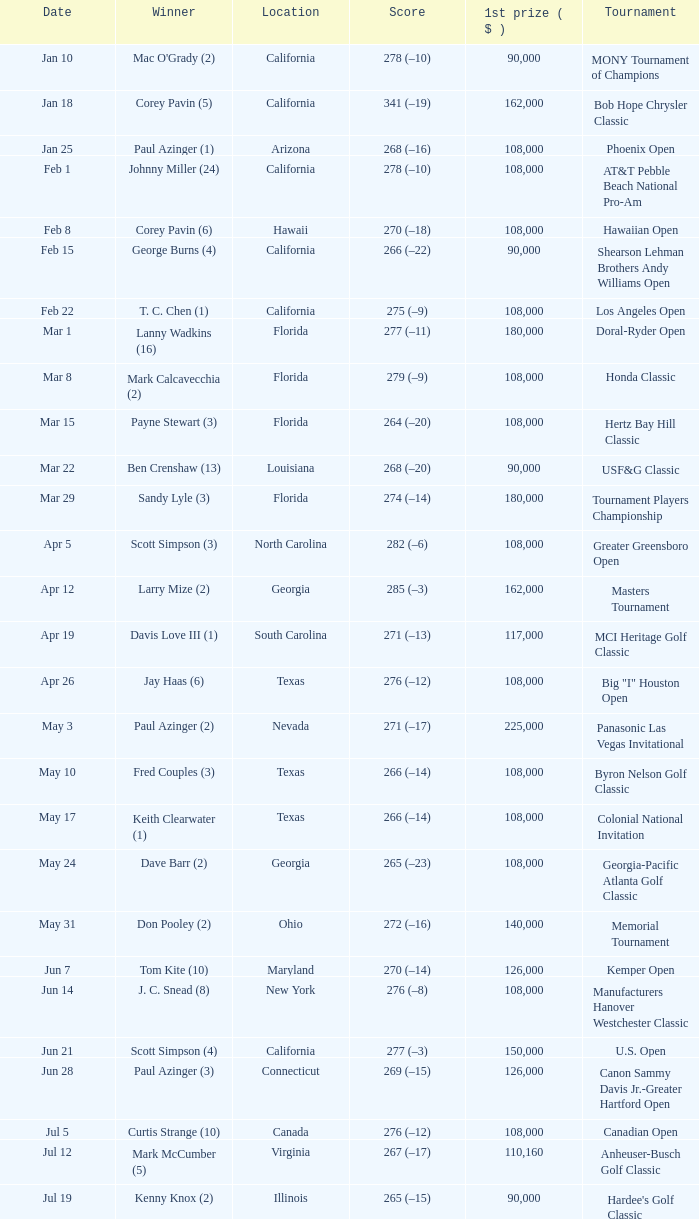What is the score from the winner Keith Clearwater (1)? 266 (–14). 